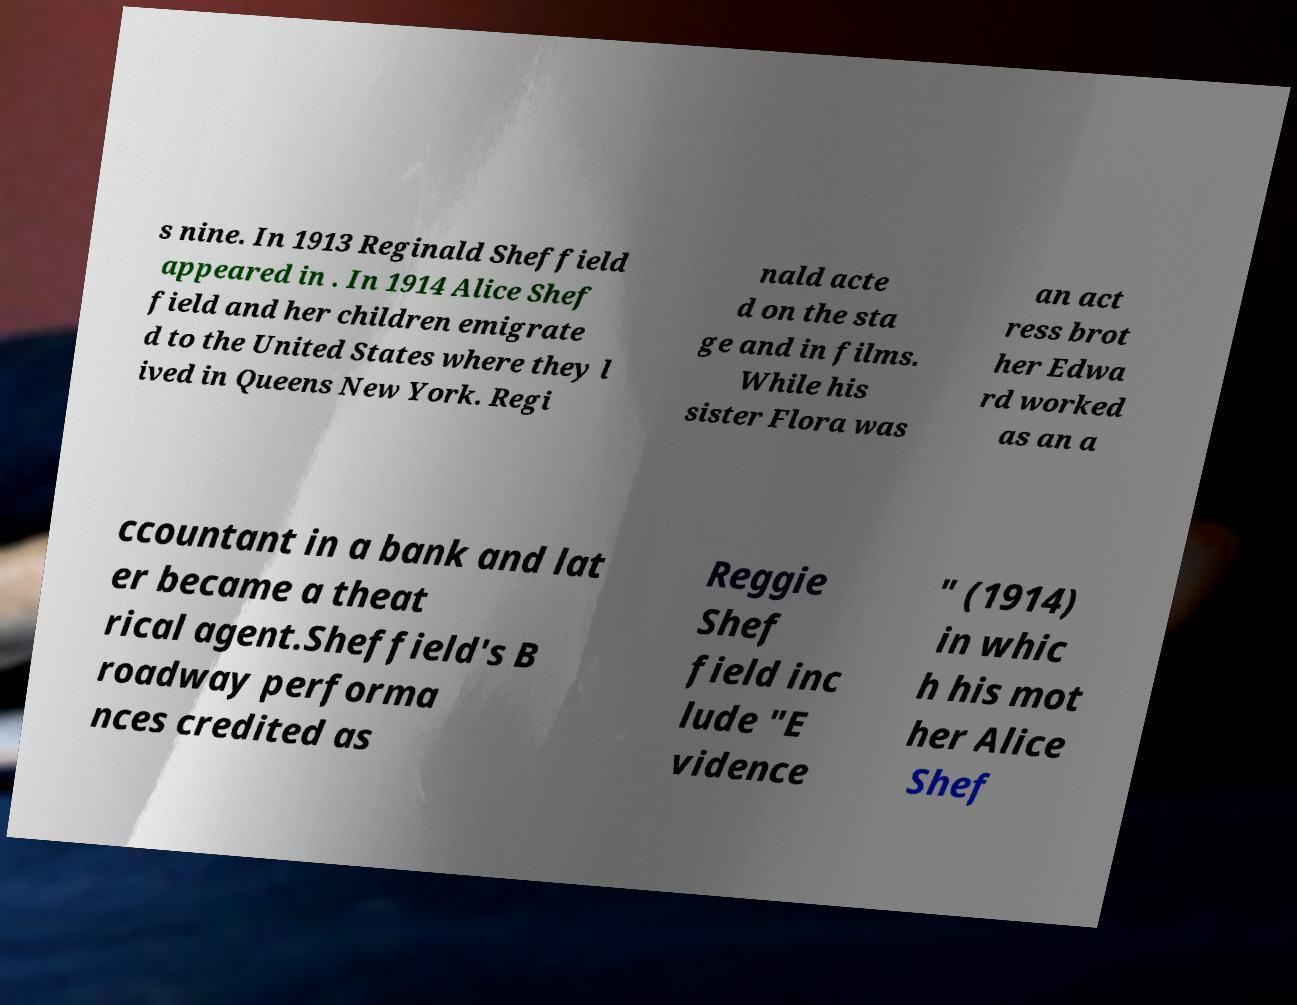Please read and relay the text visible in this image. What does it say? s nine. In 1913 Reginald Sheffield appeared in . In 1914 Alice Shef field and her children emigrate d to the United States where they l ived in Queens New York. Regi nald acte d on the sta ge and in films. While his sister Flora was an act ress brot her Edwa rd worked as an a ccountant in a bank and lat er became a theat rical agent.Sheffield's B roadway performa nces credited as Reggie Shef field inc lude "E vidence " (1914) in whic h his mot her Alice Shef 